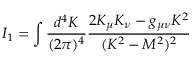<formula> <loc_0><loc_0><loc_500><loc_500>I _ { 1 } = \int \frac { d ^ { 4 } K } { ( 2 \pi ) ^ { 4 } } \frac { 2 K _ { \mu } K _ { \nu } - g _ { \mu \nu } K ^ { 2 } } { ( K ^ { 2 } - M ^ { 2 } ) ^ { 2 } }</formula> 